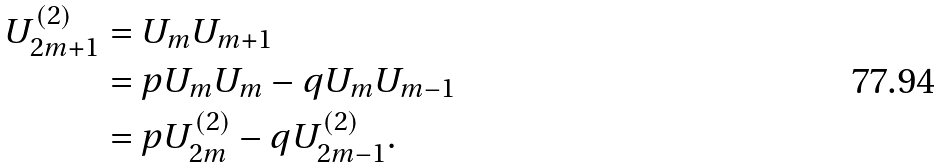<formula> <loc_0><loc_0><loc_500><loc_500>U _ { 2 m + 1 } ^ { ( 2 ) } & = U _ { m } U _ { m + 1 } \\ & = p U _ { m } U _ { m } - q U _ { m } U _ { m - 1 } \\ & = p U _ { 2 m } ^ { ( 2 ) } - q U _ { 2 m - 1 } ^ { ( 2 ) } .</formula> 